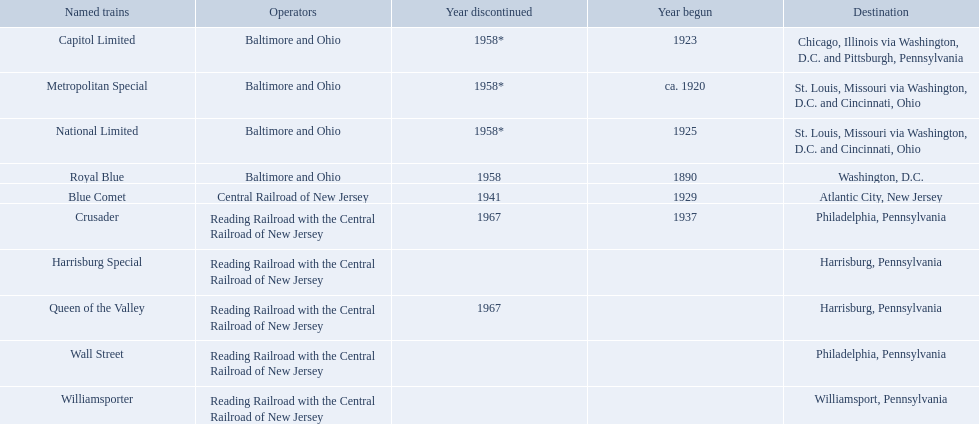What destinations are there? Chicago, Illinois via Washington, D.C. and Pittsburgh, Pennsylvania, St. Louis, Missouri via Washington, D.C. and Cincinnati, Ohio, St. Louis, Missouri via Washington, D.C. and Cincinnati, Ohio, Washington, D.C., Atlantic City, New Jersey, Philadelphia, Pennsylvania, Harrisburg, Pennsylvania, Harrisburg, Pennsylvania, Philadelphia, Pennsylvania, Williamsport, Pennsylvania. Which one is at the top of the list? Chicago, Illinois via Washington, D.C. and Pittsburgh, Pennsylvania. 